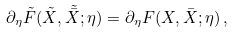<formula> <loc_0><loc_0><loc_500><loc_500>\partial _ { \eta } \tilde { F } ( \tilde { X } , \tilde { \bar { X } } ; \eta ) = \partial _ { \eta } F ( X , \bar { X } ; \eta ) \, ,</formula> 